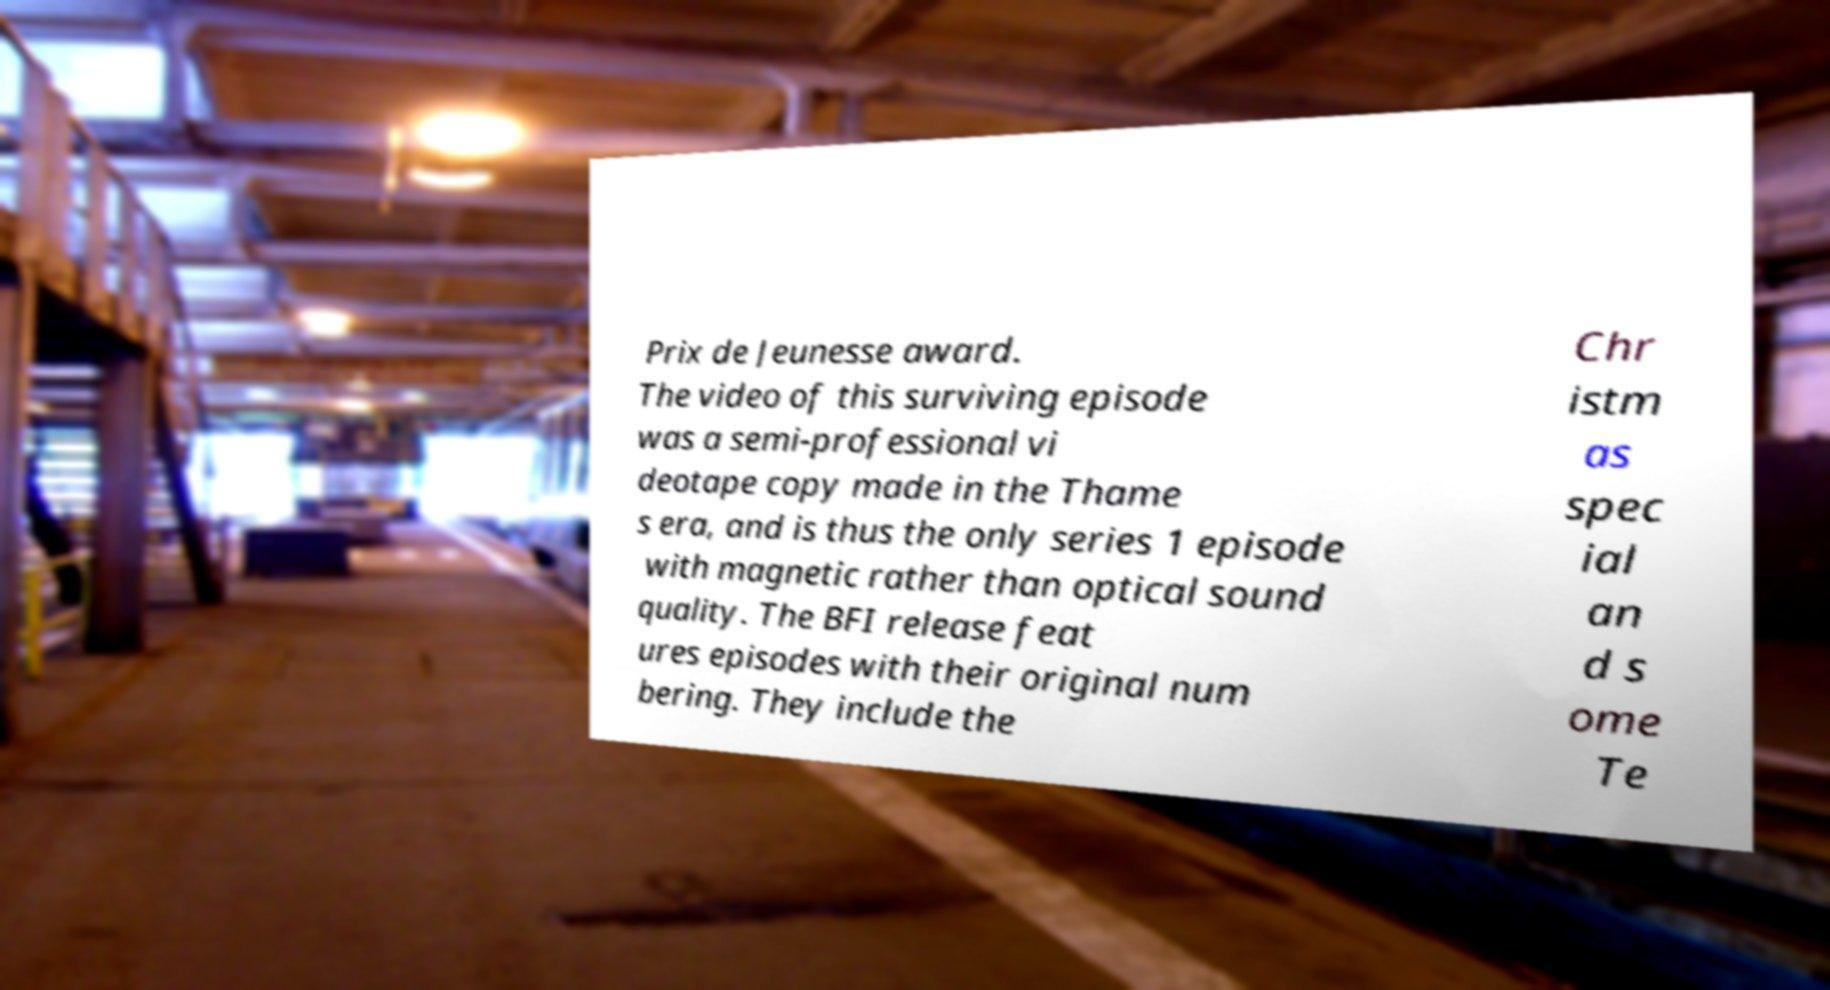I need the written content from this picture converted into text. Can you do that? Prix de Jeunesse award. The video of this surviving episode was a semi-professional vi deotape copy made in the Thame s era, and is thus the only series 1 episode with magnetic rather than optical sound quality. The BFI release feat ures episodes with their original num bering. They include the Chr istm as spec ial an d s ome Te 